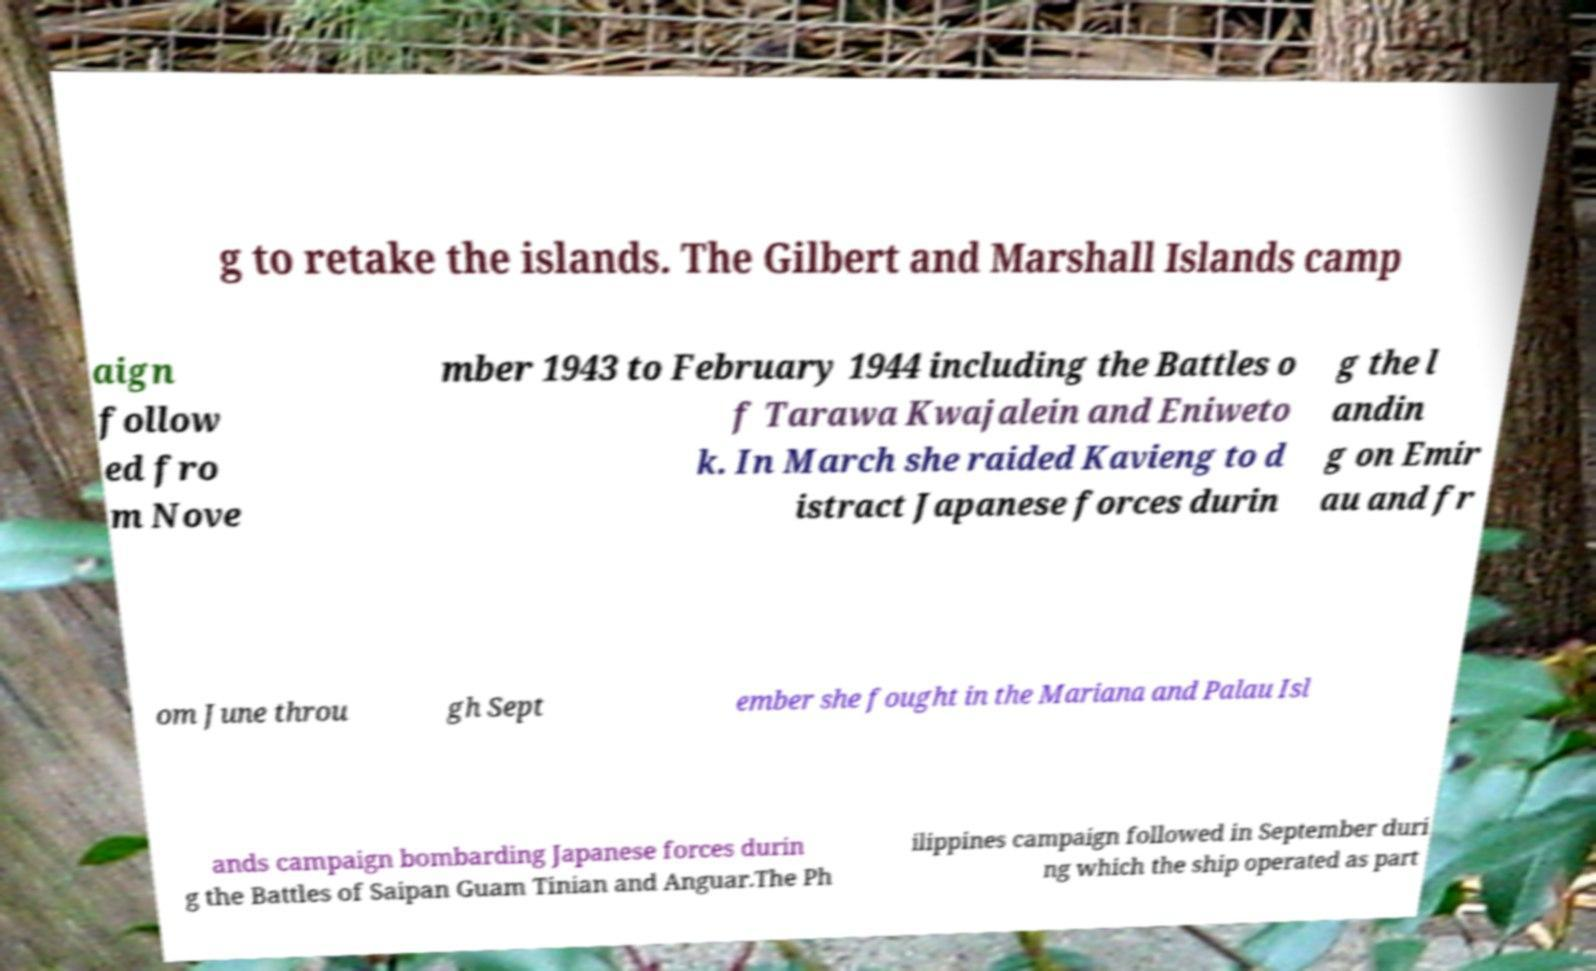Could you extract and type out the text from this image? g to retake the islands. The Gilbert and Marshall Islands camp aign follow ed fro m Nove mber 1943 to February 1944 including the Battles o f Tarawa Kwajalein and Eniweto k. In March she raided Kavieng to d istract Japanese forces durin g the l andin g on Emir au and fr om June throu gh Sept ember she fought in the Mariana and Palau Isl ands campaign bombarding Japanese forces durin g the Battles of Saipan Guam Tinian and Anguar.The Ph ilippines campaign followed in September duri ng which the ship operated as part 